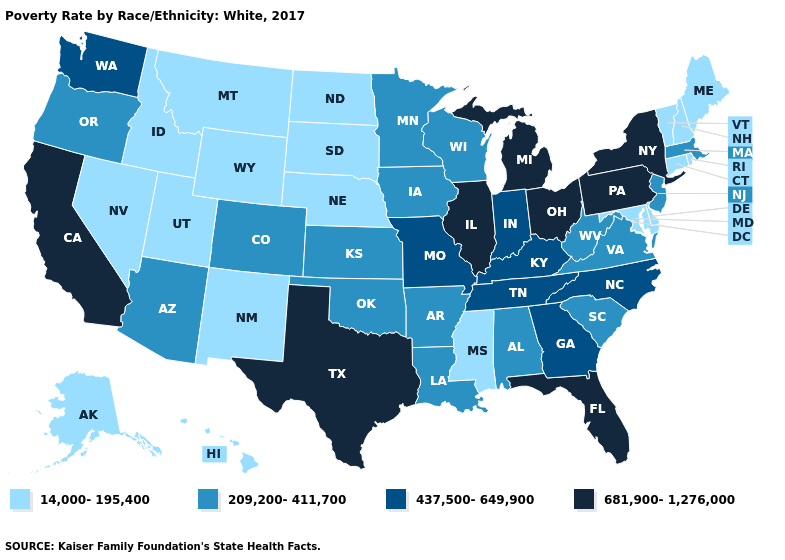What is the lowest value in states that border Louisiana?
Be succinct. 14,000-195,400. Name the states that have a value in the range 209,200-411,700?
Give a very brief answer. Alabama, Arizona, Arkansas, Colorado, Iowa, Kansas, Louisiana, Massachusetts, Minnesota, New Jersey, Oklahoma, Oregon, South Carolina, Virginia, West Virginia, Wisconsin. How many symbols are there in the legend?
Answer briefly. 4. Among the states that border Iowa , does Nebraska have the lowest value?
Concise answer only. Yes. Does Maryland have the lowest value in the USA?
Short answer required. Yes. Does the map have missing data?
Answer briefly. No. Among the states that border Wyoming , which have the highest value?
Short answer required. Colorado. Name the states that have a value in the range 209,200-411,700?
Give a very brief answer. Alabama, Arizona, Arkansas, Colorado, Iowa, Kansas, Louisiana, Massachusetts, Minnesota, New Jersey, Oklahoma, Oregon, South Carolina, Virginia, West Virginia, Wisconsin. What is the lowest value in the USA?
Write a very short answer. 14,000-195,400. Name the states that have a value in the range 437,500-649,900?
Short answer required. Georgia, Indiana, Kentucky, Missouri, North Carolina, Tennessee, Washington. What is the value of New York?
Give a very brief answer. 681,900-1,276,000. Which states have the lowest value in the USA?
Be succinct. Alaska, Connecticut, Delaware, Hawaii, Idaho, Maine, Maryland, Mississippi, Montana, Nebraska, Nevada, New Hampshire, New Mexico, North Dakota, Rhode Island, South Dakota, Utah, Vermont, Wyoming. Which states have the highest value in the USA?
Concise answer only. California, Florida, Illinois, Michigan, New York, Ohio, Pennsylvania, Texas. What is the value of Alaska?
Concise answer only. 14,000-195,400. What is the highest value in states that border Arizona?
Write a very short answer. 681,900-1,276,000. 